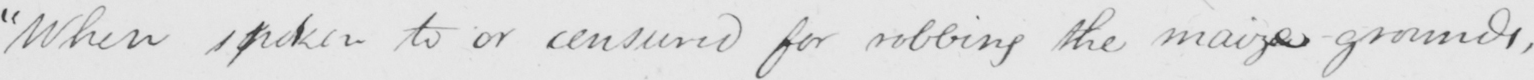Transcribe the text shown in this historical manuscript line. "When spoken to or censured for robbing the maize grounds, 